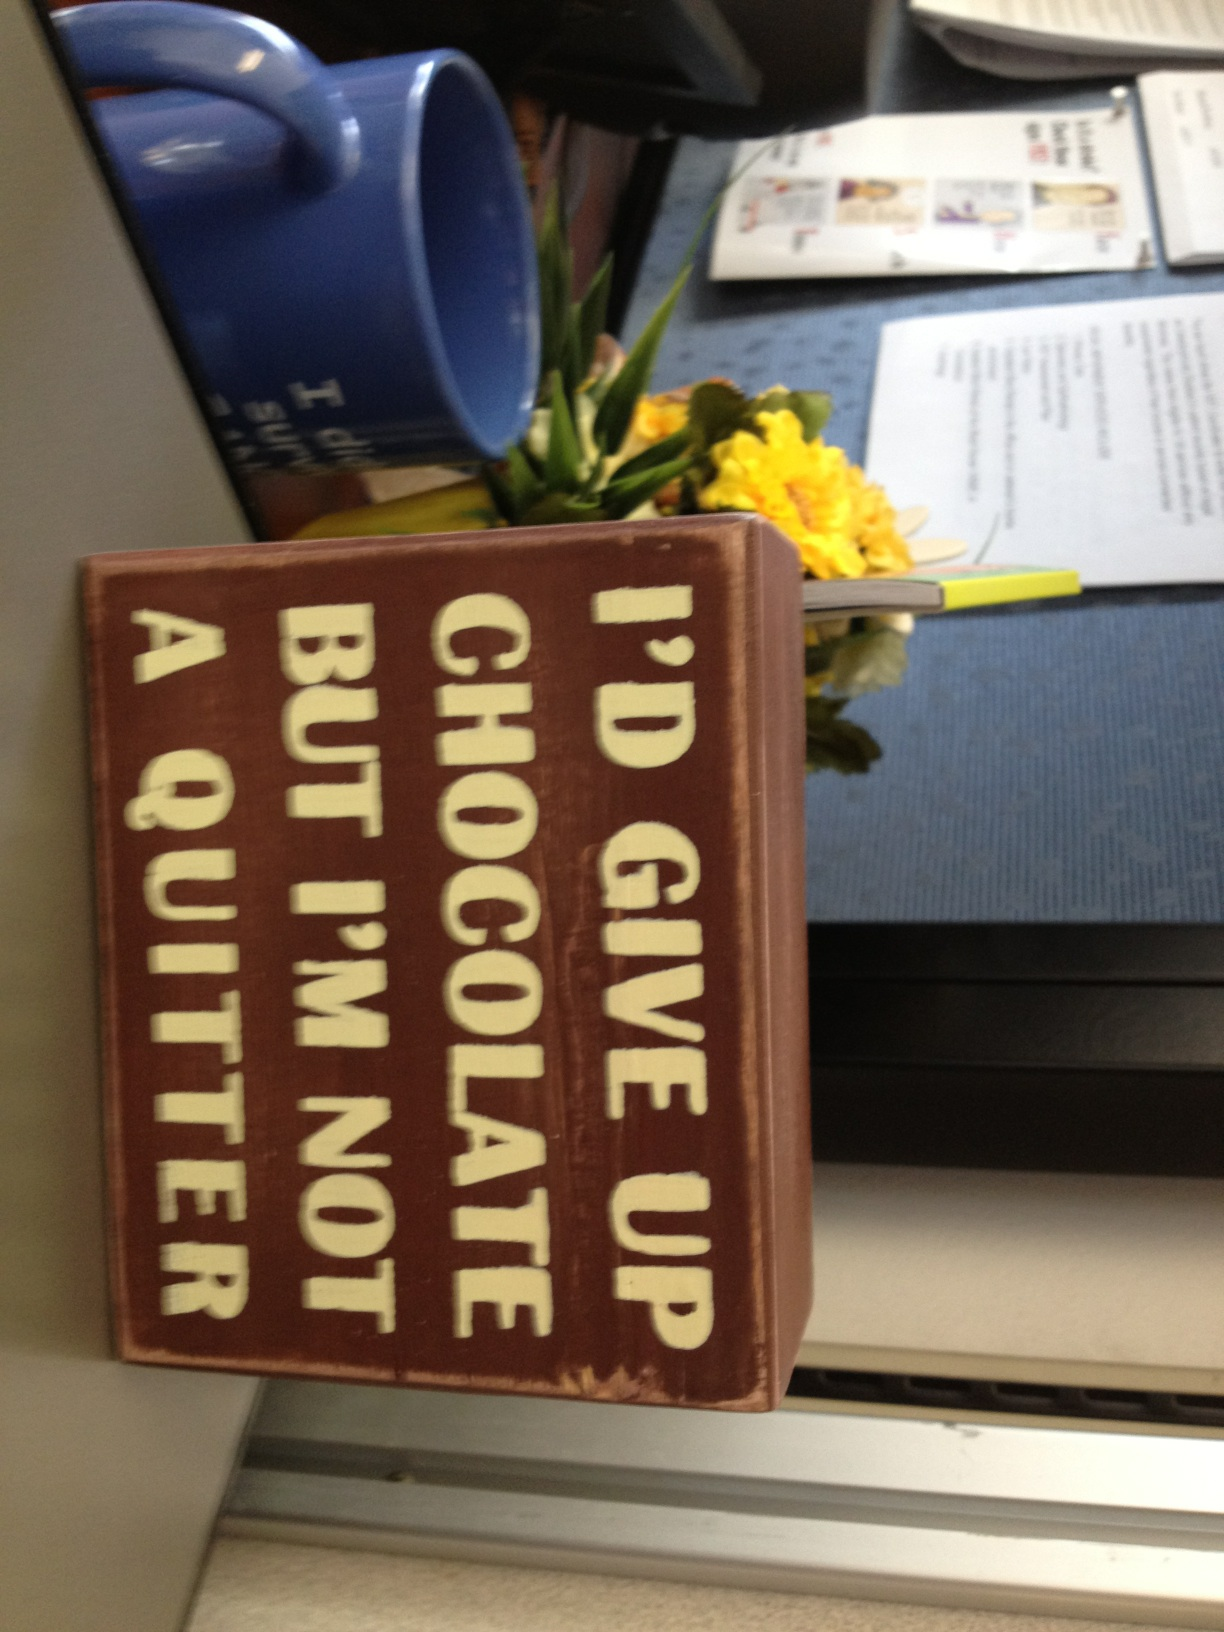Imagine if this sign could talk. What story would it tell about its life in the office? If this sign could talk, it might spin a delightful tale of office dynamics, saying: 'I've seen many faces over the years, each bringing their own quirks. I’ve stood steady through countless coffee spills, intense deadlines, and moments of triumph. My message has often served as a light-hearted reminder to take things in stride, to enjoy the little indulgences amidst the chaos of work life. I've been the centerpiece of many laughs, a silent cheerleader during late-night projects, and sometimes, a comforting presence when stress levels ran high. Life in the office can be a rollercoaster, but I've been here through it all, preaching the gospel of chocolate and resilience.' What kind of workspace setup would be ideal for a creative brainstorming session? An ideal workspace setup for a creative brainstorming session would include: 
1. **Open Space:** Ample open space to move around and interact freely. 
2. **Comfortable Seating:** A mix of seating options including chairs, bean bags, or standing desks to cater to different comfort levels. 
3. **Whiteboards and Sticky Notes:** Plenty of space to write ideas, from large whiteboards to sticky notes for free-flow idea generation. 
4. **Natural Light:** A well-lit room with lots of natural light to create an inviting environment. 
5. **Tech Tools:** Access to digital devices and high-speed internet for quick research and presentations. 
6. **Inspirational Decor:** Artworks, quotes, and other inspirational pieces to spark creativity. 
7. **Refreshments:** Easily accessible snacks and drinks to keep energy levels up. 
8. **Quiet Zones:** Areas where individuals can retreat for silent contemplation or refinements of ideas. 
This setup encourages collaboration, comfort, and a steady flow of fresh ideas. If the workplace puppy could describe the office environment, what would it say? 'Woof! This office is my playground and my napping haven. There are so many humans to pat me, and I am the center of attention during their breaks. I love the cozy corners and under-the-desk spaces where I take my naps. The air is filled with the smell of coffee and sometimes, treats appear just for me! I always get a sense of warmth and camaraderie here, and the occasional stress ball or toy to chew on keeps me happy. This place is bustling, but there’s always a moment for a belly rub or a play session. It’s a wonderful blend of work and play, and I’m lucky to be part of this pack!' Imagine if the mug in the background had a secret power. What would it be? If the mug in the background had a secret power, it would be the ability to refill itself with any beverage its holder desires at any given moment! Imagine coffee in the morning, transitioning to a soothing herbal tea in the afternoon, and maybe even a comforting hot chocolate in the evening. This magical mug would not only cater to caffeine needs but also adapt to the emotional and physical needs of its user, ensuring they're always hydrated and energized. It would become the most coveted item in the office, with everyone wondering what delightful brew it would conjure next! 